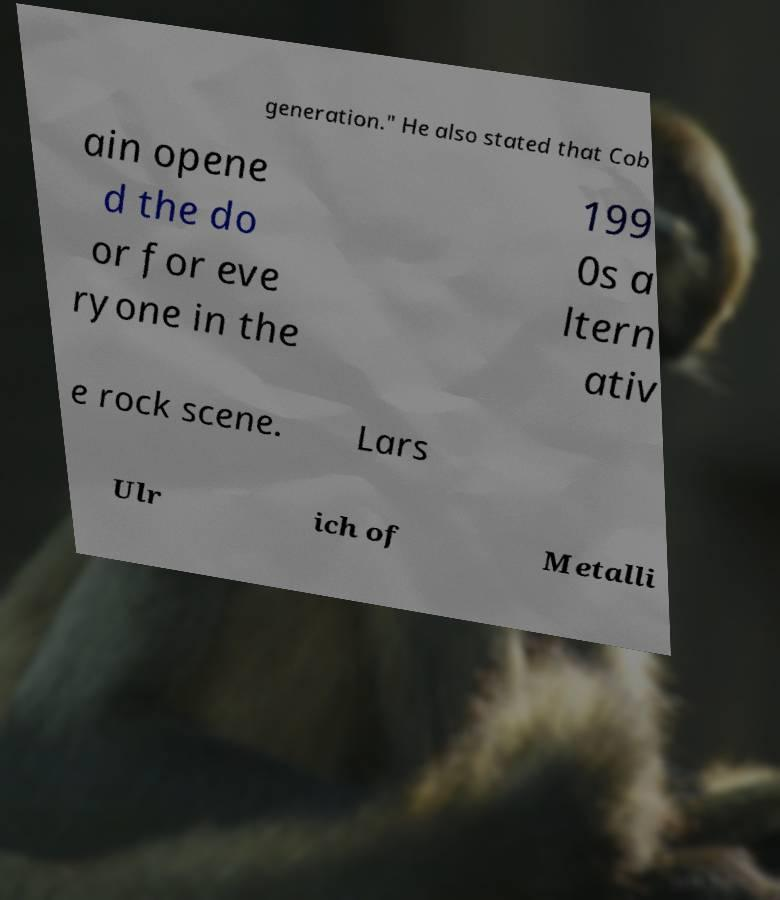There's text embedded in this image that I need extracted. Can you transcribe it verbatim? generation." He also stated that Cob ain opene d the do or for eve ryone in the 199 0s a ltern ativ e rock scene. Lars Ulr ich of Metalli 